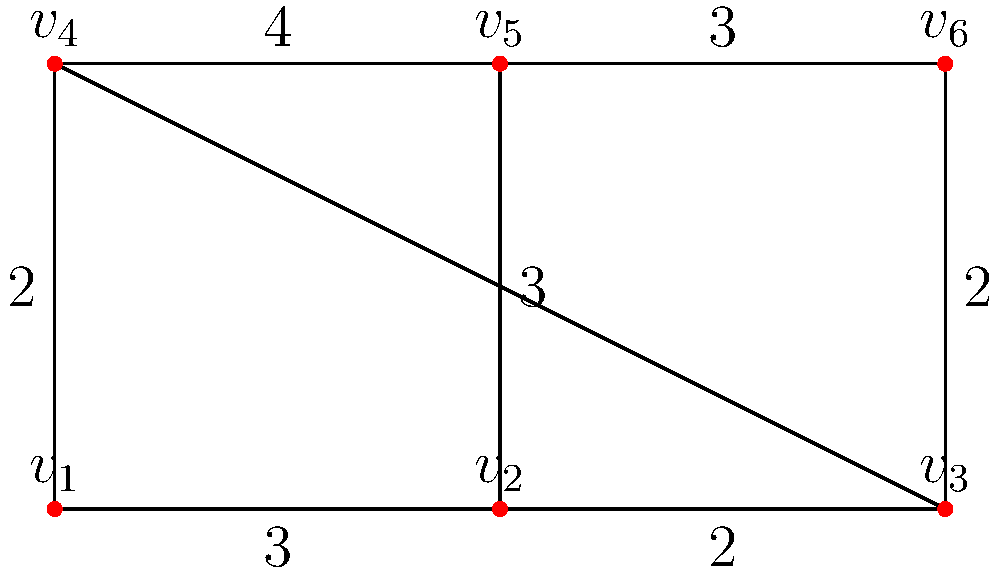Given the floor plan diagram represented by the graph above, where vertices represent potential locations for tables and edges represent pathways with their weights indicating the optimal distance between tables in meters, what is the minimum total distance required to place 4 tables while ensuring all tables are connected by pathways? To solve this problem, we need to find the minimum spanning tree (MST) that includes 4 vertices. We'll use Kruskal's algorithm:

1. Sort all edges by weight in ascending order:
   (v1,v2): 2, (v2,v5): 2, (v1,v4): 3, (v2,v3): 2, (v4,v5): 3, (v1,v2): 3, (v4,v6): 3

2. Start adding edges to the MST, avoiding cycles:
   - Add (v1,v2): 2
   - Add (v2,v5): 2
   - Add (v1,v4): 3

3. We now have 4 vertices (v1, v2, v4, v5) connected with a total distance of 7 meters.

4. Adding any more edges would create a cycle or exceed the required 4 tables.

Therefore, the minimum total distance to place 4 tables while ensuring all are connected is 7 meters.
Answer: 7 meters 